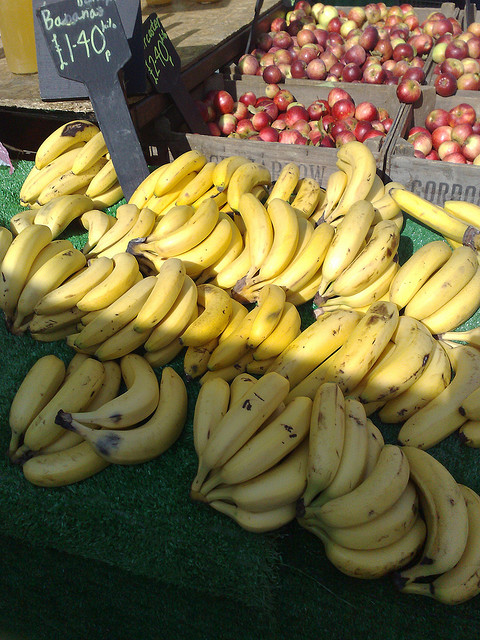How many bananas are in the photo? There are approximately 11 bananas visible in the photo, showcased on a market stand with a sign indicating their price. The bananas are ripe and ready to be enjoyed, bringing a sense of freshness and tropical flavor to the market atmosphere. 